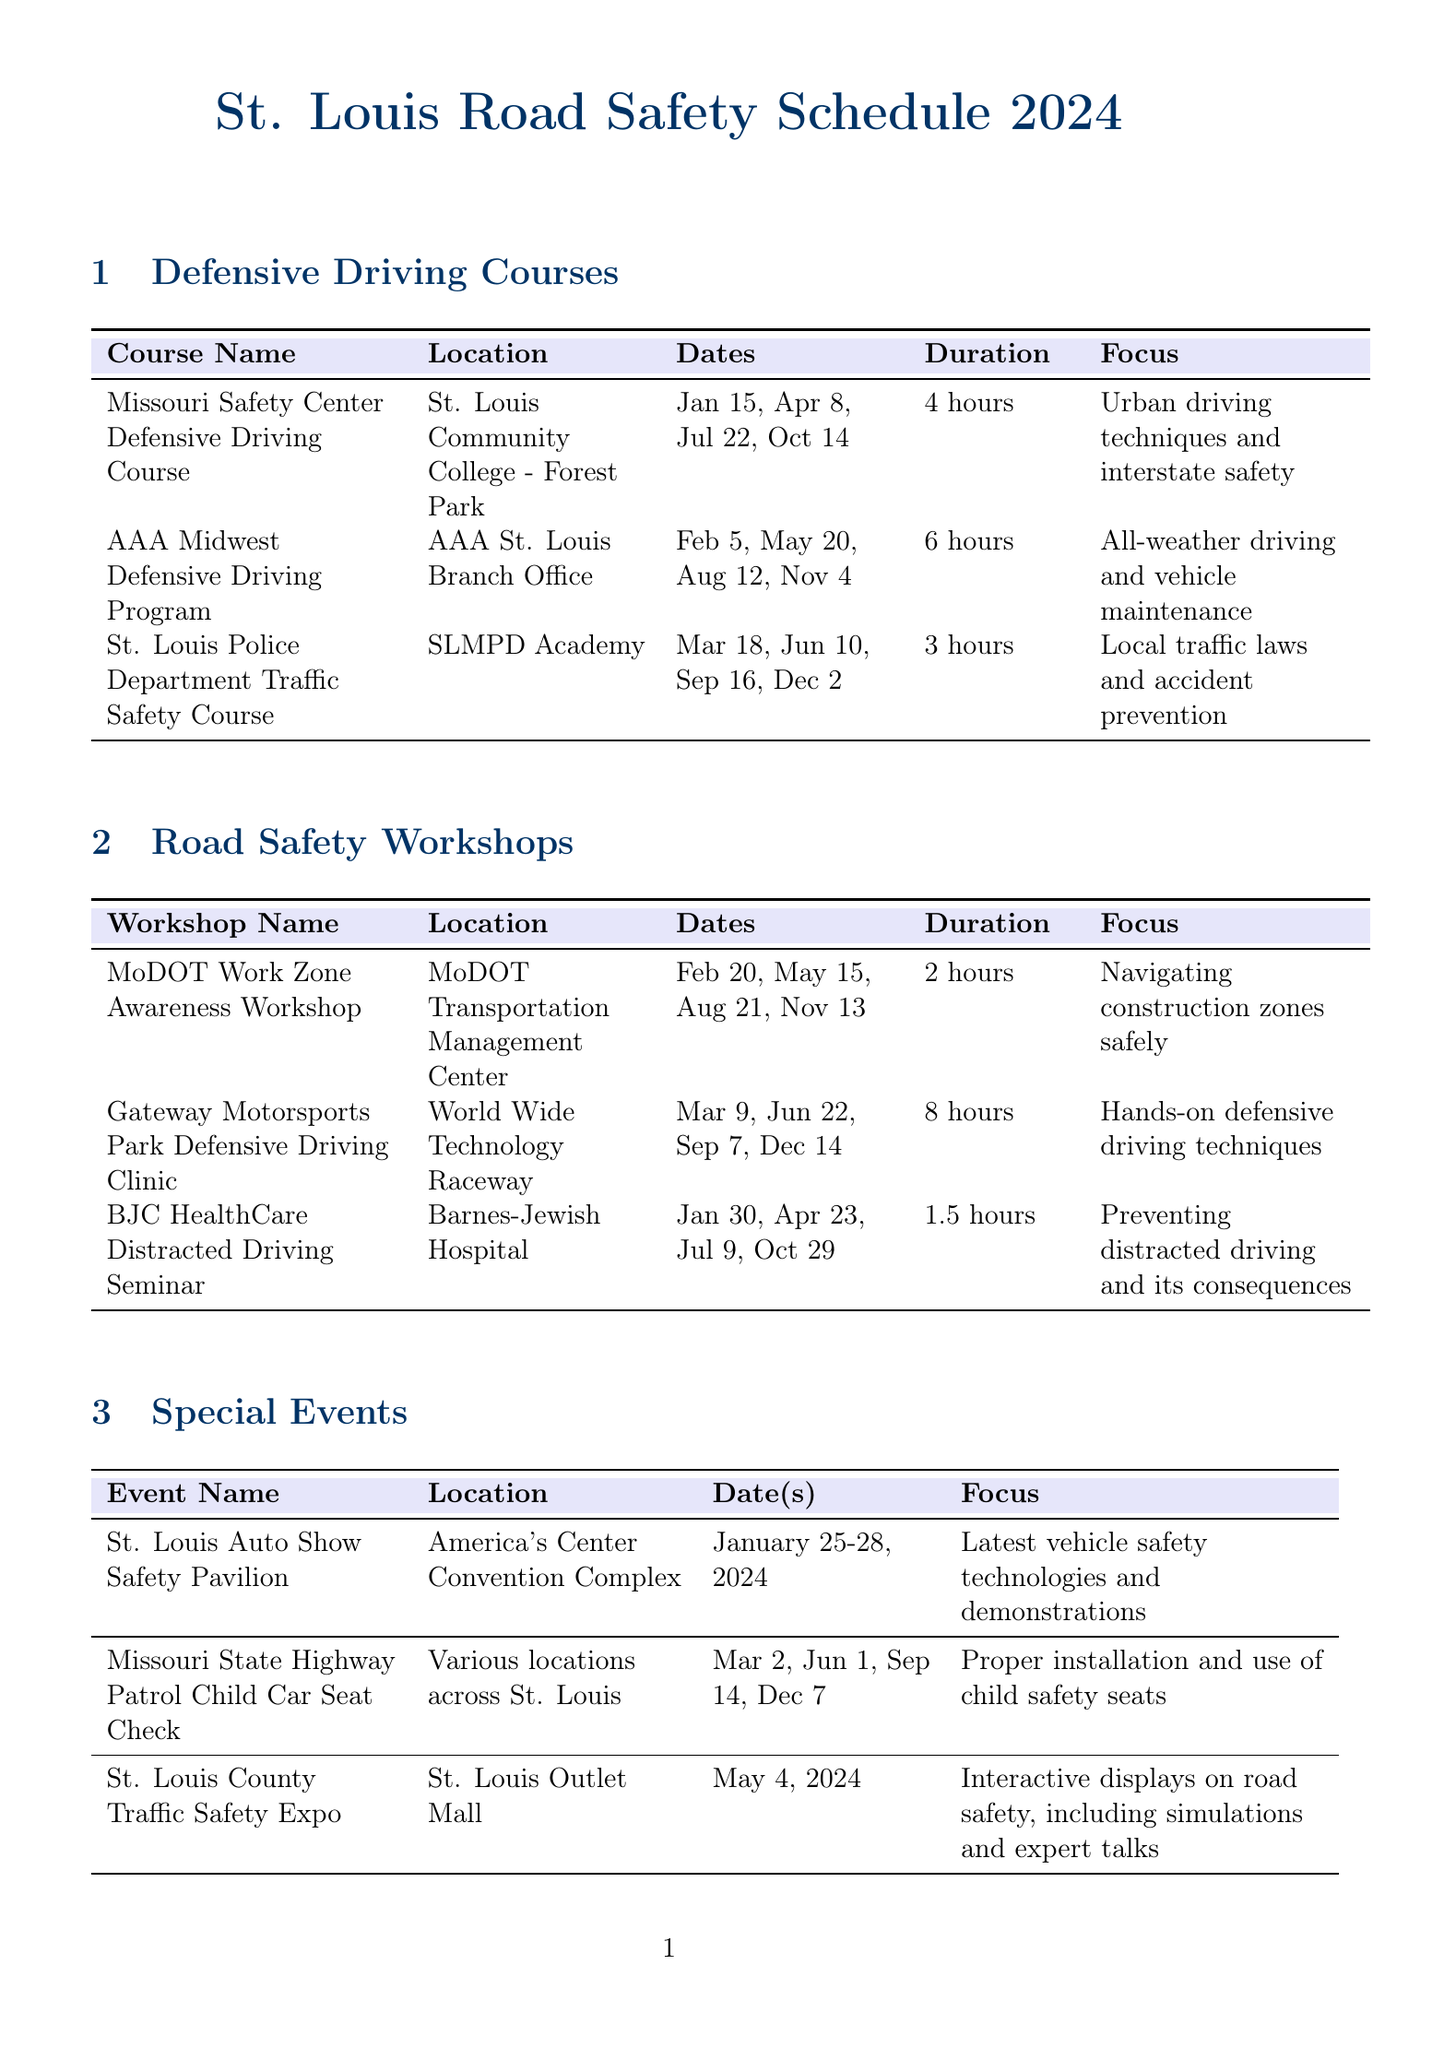what are the dates for the Missouri Safety Center Defensive Driving Course? The dates for the Missouri Safety Center Defensive Driving Course are listed in the document as January 15, April 8, July 22, and October 14.
Answer: January 15, April 8, July 22, October 14 how long is the BJC HealthCare Distracted Driving Seminar? The duration of the BJC HealthCare Distracted Driving Seminar is stated as 1.5 hours in the document.
Answer: 1.5 hours where is the AAA Midwest Defensive Driving Program held? The location for the AAA Midwest Defensive Driving Program is provided in the document as the AAA St. Louis Branch Office.
Answer: AAA St. Louis Branch Office which workshop focuses on navigating construction zones safely? The document mentions that the MoDOT Work Zone Awareness Workshop has a focus on navigating construction zones safely.
Answer: MoDOT Work Zone Awareness Workshop when is the St. Louis Auto Show Safety Pavilion? The dates for the St. Louis Auto Show Safety Pavilion are indicated as January 25-28, 2024, in the document.
Answer: January 25-28, 2024 how many hours is the Gateway Motorsports Park Defensive Driving Clinic? The document specifies that the duration of the Gateway Motorsports Park Defensive Driving Clinic is 8 hours.
Answer: 8 hours who organizes the Child Car Seat Check event? The document states that the Missouri State Highway Patrol organizes the Child Car Seat Check event.
Answer: Missouri State Highway Patrol 